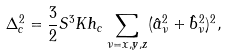<formula> <loc_0><loc_0><loc_500><loc_500>\Delta ^ { 2 } _ { c } = \frac { 3 } { 2 } S ^ { 3 } K h _ { c } \sum _ { \nu = x , y , z } ( \hat { a } ^ { 2 } _ { \nu } + \hat { b } ^ { 2 } _ { \nu } ) ^ { 2 } ,</formula> 